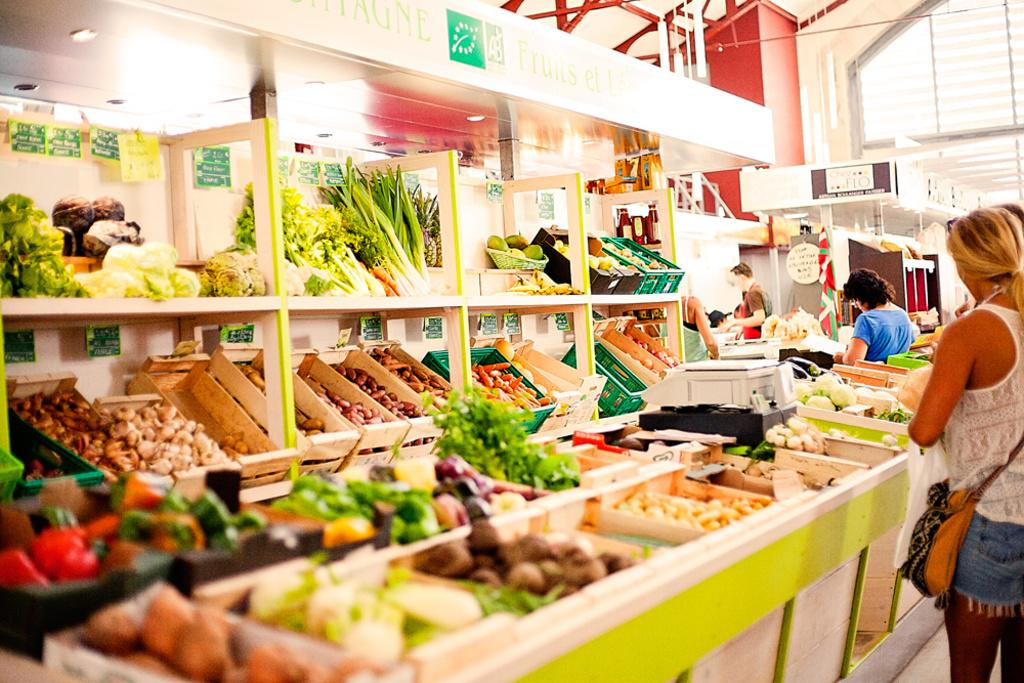What type of store is depicted in the image? The image is of a vegetable store. What items can be found in the store? There are baskets, racks, vegetables, a signboard, price tags, lights, and a weighing machine in the store. What is the purpose of the price tags in the store? The price tags in the store are used to indicate the cost of the vegetables. Are there any people present in the store? Yes, there are people in the store. What type of school is depicted in the image? There is no school depicted in the image; it is a vegetable store. Who is the manager of the school in the image? There is no school or manager present in the image. 